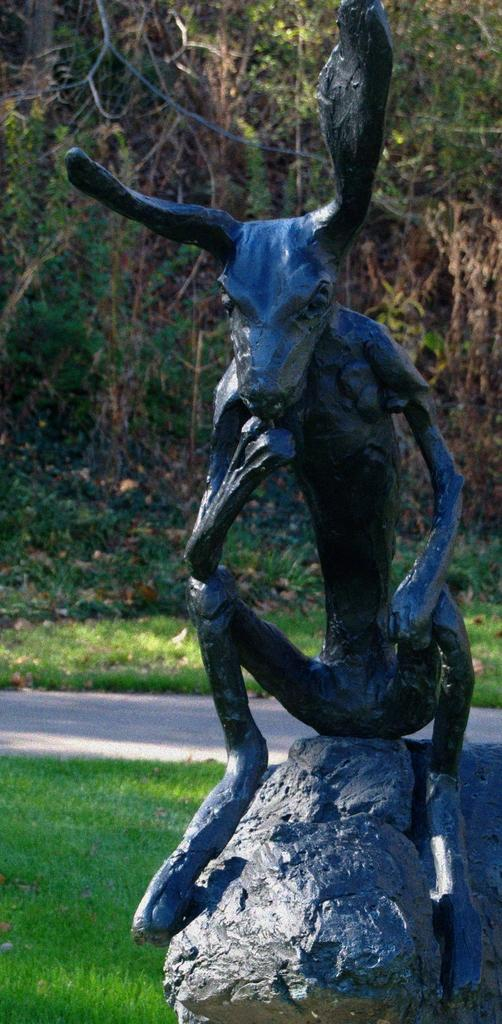What is the main subject in the image? There is a statue in the image. What is the statue placed on? The statue is placed on a stone. What can be seen in the background of the image? There is a group of trees in the background of the image. Where is the nearest waste disposal can located in the image? There is no waste disposal can present in the image. 